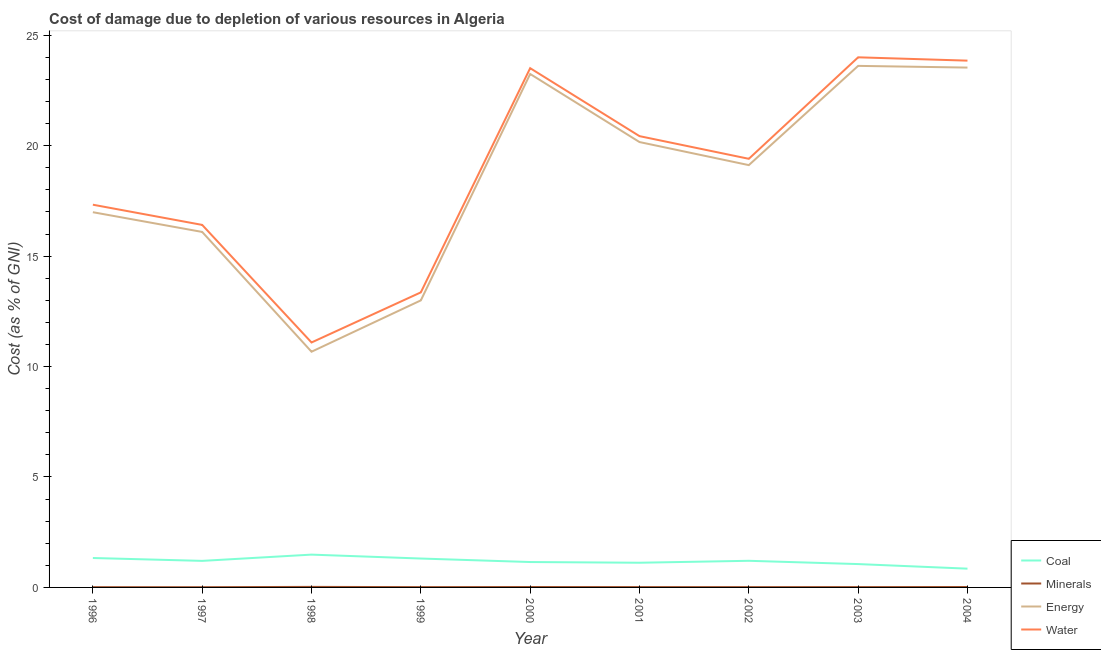How many different coloured lines are there?
Your answer should be compact. 4. What is the cost of damage due to depletion of coal in 2001?
Give a very brief answer. 1.12. Across all years, what is the maximum cost of damage due to depletion of water?
Offer a very short reply. 24. Across all years, what is the minimum cost of damage due to depletion of water?
Provide a short and direct response. 11.09. In which year was the cost of damage due to depletion of minerals maximum?
Give a very brief answer. 1998. In which year was the cost of damage due to depletion of minerals minimum?
Your answer should be compact. 1997. What is the total cost of damage due to depletion of energy in the graph?
Your response must be concise. 166.44. What is the difference between the cost of damage due to depletion of coal in 1997 and that in 1998?
Keep it short and to the point. -0.28. What is the difference between the cost of damage due to depletion of minerals in 2004 and the cost of damage due to depletion of energy in 1998?
Ensure brevity in your answer.  -10.65. What is the average cost of damage due to depletion of water per year?
Your answer should be compact. 18.82. In the year 2004, what is the difference between the cost of damage due to depletion of minerals and cost of damage due to depletion of water?
Offer a very short reply. -23.83. In how many years, is the cost of damage due to depletion of minerals greater than 16 %?
Offer a very short reply. 0. What is the ratio of the cost of damage due to depletion of energy in 1999 to that in 2004?
Give a very brief answer. 0.55. Is the cost of damage due to depletion of coal in 1998 less than that in 2000?
Your answer should be compact. No. What is the difference between the highest and the second highest cost of damage due to depletion of minerals?
Ensure brevity in your answer.  0.01. What is the difference between the highest and the lowest cost of damage due to depletion of coal?
Provide a short and direct response. 0.64. Is it the case that in every year, the sum of the cost of damage due to depletion of energy and cost of damage due to depletion of water is greater than the sum of cost of damage due to depletion of minerals and cost of damage due to depletion of coal?
Provide a short and direct response. Yes. Is the cost of damage due to depletion of coal strictly greater than the cost of damage due to depletion of minerals over the years?
Keep it short and to the point. Yes. Is the cost of damage due to depletion of coal strictly less than the cost of damage due to depletion of water over the years?
Give a very brief answer. Yes. How many lines are there?
Keep it short and to the point. 4. How many years are there in the graph?
Your response must be concise. 9. What is the difference between two consecutive major ticks on the Y-axis?
Provide a short and direct response. 5. Where does the legend appear in the graph?
Provide a succinct answer. Bottom right. What is the title of the graph?
Offer a very short reply. Cost of damage due to depletion of various resources in Algeria . Does "HFC gas" appear as one of the legend labels in the graph?
Offer a terse response. No. What is the label or title of the Y-axis?
Give a very brief answer. Cost (as % of GNI). What is the Cost (as % of GNI) of Coal in 1996?
Give a very brief answer. 1.33. What is the Cost (as % of GNI) of Minerals in 1996?
Offer a terse response. 0.01. What is the Cost (as % of GNI) of Energy in 1996?
Ensure brevity in your answer.  16.99. What is the Cost (as % of GNI) in Water in 1996?
Offer a terse response. 17.33. What is the Cost (as % of GNI) in Coal in 1997?
Your answer should be very brief. 1.2. What is the Cost (as % of GNI) in Minerals in 1997?
Offer a terse response. 0.01. What is the Cost (as % of GNI) of Energy in 1997?
Provide a short and direct response. 16.1. What is the Cost (as % of GNI) in Water in 1997?
Give a very brief answer. 16.41. What is the Cost (as % of GNI) of Coal in 1998?
Provide a short and direct response. 1.49. What is the Cost (as % of GNI) of Minerals in 1998?
Keep it short and to the point. 0.02. What is the Cost (as % of GNI) of Energy in 1998?
Offer a terse response. 10.67. What is the Cost (as % of GNI) in Water in 1998?
Give a very brief answer. 11.09. What is the Cost (as % of GNI) of Coal in 1999?
Keep it short and to the point. 1.31. What is the Cost (as % of GNI) of Minerals in 1999?
Your response must be concise. 0.01. What is the Cost (as % of GNI) of Energy in 1999?
Make the answer very short. 13. What is the Cost (as % of GNI) in Water in 1999?
Provide a short and direct response. 13.36. What is the Cost (as % of GNI) in Coal in 2000?
Provide a succinct answer. 1.15. What is the Cost (as % of GNI) in Minerals in 2000?
Offer a very short reply. 0.02. What is the Cost (as % of GNI) in Energy in 2000?
Provide a succinct answer. 23.25. What is the Cost (as % of GNI) in Water in 2000?
Your answer should be very brief. 23.51. What is the Cost (as % of GNI) in Coal in 2001?
Keep it short and to the point. 1.12. What is the Cost (as % of GNI) in Minerals in 2001?
Keep it short and to the point. 0.02. What is the Cost (as % of GNI) in Energy in 2001?
Offer a very short reply. 20.17. What is the Cost (as % of GNI) of Water in 2001?
Your answer should be very brief. 20.43. What is the Cost (as % of GNI) in Coal in 2002?
Offer a terse response. 1.21. What is the Cost (as % of GNI) of Minerals in 2002?
Give a very brief answer. 0.01. What is the Cost (as % of GNI) in Energy in 2002?
Make the answer very short. 19.12. What is the Cost (as % of GNI) in Water in 2002?
Your answer should be compact. 19.41. What is the Cost (as % of GNI) in Coal in 2003?
Your answer should be compact. 1.06. What is the Cost (as % of GNI) of Minerals in 2003?
Provide a short and direct response. 0.02. What is the Cost (as % of GNI) in Energy in 2003?
Give a very brief answer. 23.61. What is the Cost (as % of GNI) of Water in 2003?
Offer a terse response. 24. What is the Cost (as % of GNI) of Coal in 2004?
Your response must be concise. 0.85. What is the Cost (as % of GNI) of Minerals in 2004?
Offer a terse response. 0.02. What is the Cost (as % of GNI) of Energy in 2004?
Your response must be concise. 23.54. What is the Cost (as % of GNI) in Water in 2004?
Your answer should be very brief. 23.85. Across all years, what is the maximum Cost (as % of GNI) in Coal?
Your answer should be compact. 1.49. Across all years, what is the maximum Cost (as % of GNI) in Minerals?
Offer a terse response. 0.02. Across all years, what is the maximum Cost (as % of GNI) of Energy?
Keep it short and to the point. 23.61. Across all years, what is the maximum Cost (as % of GNI) of Water?
Make the answer very short. 24. Across all years, what is the minimum Cost (as % of GNI) in Coal?
Provide a short and direct response. 0.85. Across all years, what is the minimum Cost (as % of GNI) of Minerals?
Ensure brevity in your answer.  0.01. Across all years, what is the minimum Cost (as % of GNI) of Energy?
Your response must be concise. 10.67. Across all years, what is the minimum Cost (as % of GNI) in Water?
Your answer should be very brief. 11.09. What is the total Cost (as % of GNI) in Coal in the graph?
Your response must be concise. 10.71. What is the total Cost (as % of GNI) of Minerals in the graph?
Keep it short and to the point. 0.14. What is the total Cost (as % of GNI) of Energy in the graph?
Your response must be concise. 166.44. What is the total Cost (as % of GNI) of Water in the graph?
Keep it short and to the point. 169.4. What is the difference between the Cost (as % of GNI) of Coal in 1996 and that in 1997?
Make the answer very short. 0.13. What is the difference between the Cost (as % of GNI) of Minerals in 1996 and that in 1997?
Your answer should be compact. 0. What is the difference between the Cost (as % of GNI) in Energy in 1996 and that in 1997?
Provide a succinct answer. 0.89. What is the difference between the Cost (as % of GNI) of Water in 1996 and that in 1997?
Provide a short and direct response. 0.91. What is the difference between the Cost (as % of GNI) of Coal in 1996 and that in 1998?
Keep it short and to the point. -0.15. What is the difference between the Cost (as % of GNI) of Minerals in 1996 and that in 1998?
Offer a terse response. -0.01. What is the difference between the Cost (as % of GNI) of Energy in 1996 and that in 1998?
Ensure brevity in your answer.  6.32. What is the difference between the Cost (as % of GNI) in Water in 1996 and that in 1998?
Make the answer very short. 6.24. What is the difference between the Cost (as % of GNI) in Coal in 1996 and that in 1999?
Make the answer very short. 0.02. What is the difference between the Cost (as % of GNI) in Minerals in 1996 and that in 1999?
Offer a very short reply. -0. What is the difference between the Cost (as % of GNI) in Energy in 1996 and that in 1999?
Provide a succinct answer. 3.99. What is the difference between the Cost (as % of GNI) in Water in 1996 and that in 1999?
Your answer should be compact. 3.97. What is the difference between the Cost (as % of GNI) of Coal in 1996 and that in 2000?
Offer a very short reply. 0.18. What is the difference between the Cost (as % of GNI) of Minerals in 1996 and that in 2000?
Your response must be concise. -0.01. What is the difference between the Cost (as % of GNI) of Energy in 1996 and that in 2000?
Offer a terse response. -6.26. What is the difference between the Cost (as % of GNI) of Water in 1996 and that in 2000?
Offer a very short reply. -6.18. What is the difference between the Cost (as % of GNI) of Coal in 1996 and that in 2001?
Your answer should be very brief. 0.21. What is the difference between the Cost (as % of GNI) in Minerals in 1996 and that in 2001?
Provide a short and direct response. -0. What is the difference between the Cost (as % of GNI) of Energy in 1996 and that in 2001?
Your answer should be compact. -3.18. What is the difference between the Cost (as % of GNI) of Water in 1996 and that in 2001?
Ensure brevity in your answer.  -3.1. What is the difference between the Cost (as % of GNI) of Coal in 1996 and that in 2002?
Ensure brevity in your answer.  0.13. What is the difference between the Cost (as % of GNI) of Minerals in 1996 and that in 2002?
Make the answer very short. -0. What is the difference between the Cost (as % of GNI) of Energy in 1996 and that in 2002?
Keep it short and to the point. -2.13. What is the difference between the Cost (as % of GNI) of Water in 1996 and that in 2002?
Offer a very short reply. -2.08. What is the difference between the Cost (as % of GNI) in Coal in 1996 and that in 2003?
Make the answer very short. 0.28. What is the difference between the Cost (as % of GNI) in Minerals in 1996 and that in 2003?
Offer a very short reply. -0. What is the difference between the Cost (as % of GNI) in Energy in 1996 and that in 2003?
Your answer should be very brief. -6.63. What is the difference between the Cost (as % of GNI) in Water in 1996 and that in 2003?
Provide a short and direct response. -6.67. What is the difference between the Cost (as % of GNI) in Coal in 1996 and that in 2004?
Offer a very short reply. 0.48. What is the difference between the Cost (as % of GNI) in Minerals in 1996 and that in 2004?
Your answer should be very brief. -0.01. What is the difference between the Cost (as % of GNI) of Energy in 1996 and that in 2004?
Your answer should be very brief. -6.55. What is the difference between the Cost (as % of GNI) in Water in 1996 and that in 2004?
Offer a very short reply. -6.52. What is the difference between the Cost (as % of GNI) of Coal in 1997 and that in 1998?
Offer a terse response. -0.28. What is the difference between the Cost (as % of GNI) in Minerals in 1997 and that in 1998?
Make the answer very short. -0.01. What is the difference between the Cost (as % of GNI) in Energy in 1997 and that in 1998?
Your answer should be very brief. 5.42. What is the difference between the Cost (as % of GNI) in Water in 1997 and that in 1998?
Offer a terse response. 5.32. What is the difference between the Cost (as % of GNI) of Coal in 1997 and that in 1999?
Keep it short and to the point. -0.11. What is the difference between the Cost (as % of GNI) in Minerals in 1997 and that in 1999?
Offer a terse response. -0. What is the difference between the Cost (as % of GNI) of Energy in 1997 and that in 1999?
Keep it short and to the point. 3.1. What is the difference between the Cost (as % of GNI) of Water in 1997 and that in 1999?
Keep it short and to the point. 3.05. What is the difference between the Cost (as % of GNI) in Coal in 1997 and that in 2000?
Keep it short and to the point. 0.05. What is the difference between the Cost (as % of GNI) of Minerals in 1997 and that in 2000?
Provide a succinct answer. -0.01. What is the difference between the Cost (as % of GNI) of Energy in 1997 and that in 2000?
Provide a succinct answer. -7.15. What is the difference between the Cost (as % of GNI) of Water in 1997 and that in 2000?
Ensure brevity in your answer.  -7.1. What is the difference between the Cost (as % of GNI) of Coal in 1997 and that in 2001?
Your answer should be compact. 0.08. What is the difference between the Cost (as % of GNI) of Minerals in 1997 and that in 2001?
Keep it short and to the point. -0. What is the difference between the Cost (as % of GNI) in Energy in 1997 and that in 2001?
Your answer should be very brief. -4.07. What is the difference between the Cost (as % of GNI) in Water in 1997 and that in 2001?
Give a very brief answer. -4.02. What is the difference between the Cost (as % of GNI) of Coal in 1997 and that in 2002?
Your response must be concise. -0. What is the difference between the Cost (as % of GNI) in Minerals in 1997 and that in 2002?
Offer a very short reply. -0. What is the difference between the Cost (as % of GNI) of Energy in 1997 and that in 2002?
Provide a succinct answer. -3.03. What is the difference between the Cost (as % of GNI) in Water in 1997 and that in 2002?
Make the answer very short. -2.99. What is the difference between the Cost (as % of GNI) of Coal in 1997 and that in 2003?
Offer a terse response. 0.15. What is the difference between the Cost (as % of GNI) of Minerals in 1997 and that in 2003?
Your response must be concise. -0.01. What is the difference between the Cost (as % of GNI) of Energy in 1997 and that in 2003?
Offer a terse response. -7.52. What is the difference between the Cost (as % of GNI) in Water in 1997 and that in 2003?
Your answer should be very brief. -7.59. What is the difference between the Cost (as % of GNI) in Coal in 1997 and that in 2004?
Your answer should be very brief. 0.35. What is the difference between the Cost (as % of GNI) of Minerals in 1997 and that in 2004?
Offer a terse response. -0.01. What is the difference between the Cost (as % of GNI) of Energy in 1997 and that in 2004?
Provide a short and direct response. -7.44. What is the difference between the Cost (as % of GNI) of Water in 1997 and that in 2004?
Your answer should be very brief. -7.44. What is the difference between the Cost (as % of GNI) in Coal in 1998 and that in 1999?
Provide a short and direct response. 0.18. What is the difference between the Cost (as % of GNI) of Minerals in 1998 and that in 1999?
Your response must be concise. 0.01. What is the difference between the Cost (as % of GNI) in Energy in 1998 and that in 1999?
Keep it short and to the point. -2.32. What is the difference between the Cost (as % of GNI) of Water in 1998 and that in 1999?
Keep it short and to the point. -2.27. What is the difference between the Cost (as % of GNI) in Coal in 1998 and that in 2000?
Your response must be concise. 0.34. What is the difference between the Cost (as % of GNI) in Minerals in 1998 and that in 2000?
Ensure brevity in your answer.  0.01. What is the difference between the Cost (as % of GNI) in Energy in 1998 and that in 2000?
Provide a short and direct response. -12.58. What is the difference between the Cost (as % of GNI) of Water in 1998 and that in 2000?
Ensure brevity in your answer.  -12.42. What is the difference between the Cost (as % of GNI) of Coal in 1998 and that in 2001?
Give a very brief answer. 0.37. What is the difference between the Cost (as % of GNI) of Minerals in 1998 and that in 2001?
Offer a very short reply. 0.01. What is the difference between the Cost (as % of GNI) of Energy in 1998 and that in 2001?
Offer a very short reply. -9.49. What is the difference between the Cost (as % of GNI) of Water in 1998 and that in 2001?
Keep it short and to the point. -9.34. What is the difference between the Cost (as % of GNI) in Coal in 1998 and that in 2002?
Provide a succinct answer. 0.28. What is the difference between the Cost (as % of GNI) in Minerals in 1998 and that in 2002?
Offer a terse response. 0.01. What is the difference between the Cost (as % of GNI) in Energy in 1998 and that in 2002?
Provide a succinct answer. -8.45. What is the difference between the Cost (as % of GNI) of Water in 1998 and that in 2002?
Make the answer very short. -8.32. What is the difference between the Cost (as % of GNI) of Coal in 1998 and that in 2003?
Keep it short and to the point. 0.43. What is the difference between the Cost (as % of GNI) in Minerals in 1998 and that in 2003?
Offer a very short reply. 0.01. What is the difference between the Cost (as % of GNI) of Energy in 1998 and that in 2003?
Provide a short and direct response. -12.94. What is the difference between the Cost (as % of GNI) of Water in 1998 and that in 2003?
Make the answer very short. -12.91. What is the difference between the Cost (as % of GNI) of Coal in 1998 and that in 2004?
Ensure brevity in your answer.  0.64. What is the difference between the Cost (as % of GNI) in Minerals in 1998 and that in 2004?
Provide a succinct answer. 0.01. What is the difference between the Cost (as % of GNI) of Energy in 1998 and that in 2004?
Your answer should be very brief. -12.87. What is the difference between the Cost (as % of GNI) in Water in 1998 and that in 2004?
Offer a terse response. -12.76. What is the difference between the Cost (as % of GNI) of Coal in 1999 and that in 2000?
Offer a very short reply. 0.16. What is the difference between the Cost (as % of GNI) in Minerals in 1999 and that in 2000?
Offer a very short reply. -0. What is the difference between the Cost (as % of GNI) in Energy in 1999 and that in 2000?
Offer a terse response. -10.25. What is the difference between the Cost (as % of GNI) in Water in 1999 and that in 2000?
Keep it short and to the point. -10.15. What is the difference between the Cost (as % of GNI) in Coal in 1999 and that in 2001?
Offer a very short reply. 0.19. What is the difference between the Cost (as % of GNI) in Minerals in 1999 and that in 2001?
Make the answer very short. -0. What is the difference between the Cost (as % of GNI) of Energy in 1999 and that in 2001?
Offer a terse response. -7.17. What is the difference between the Cost (as % of GNI) in Water in 1999 and that in 2001?
Your answer should be compact. -7.07. What is the difference between the Cost (as % of GNI) in Coal in 1999 and that in 2002?
Offer a very short reply. 0.1. What is the difference between the Cost (as % of GNI) of Minerals in 1999 and that in 2002?
Your answer should be very brief. -0. What is the difference between the Cost (as % of GNI) in Energy in 1999 and that in 2002?
Offer a very short reply. -6.12. What is the difference between the Cost (as % of GNI) in Water in 1999 and that in 2002?
Make the answer very short. -6.05. What is the difference between the Cost (as % of GNI) of Coal in 1999 and that in 2003?
Provide a succinct answer. 0.25. What is the difference between the Cost (as % of GNI) in Minerals in 1999 and that in 2003?
Provide a short and direct response. -0. What is the difference between the Cost (as % of GNI) in Energy in 1999 and that in 2003?
Your answer should be very brief. -10.62. What is the difference between the Cost (as % of GNI) in Water in 1999 and that in 2003?
Provide a succinct answer. -10.64. What is the difference between the Cost (as % of GNI) in Coal in 1999 and that in 2004?
Your answer should be compact. 0.46. What is the difference between the Cost (as % of GNI) in Minerals in 1999 and that in 2004?
Give a very brief answer. -0. What is the difference between the Cost (as % of GNI) in Energy in 1999 and that in 2004?
Keep it short and to the point. -10.54. What is the difference between the Cost (as % of GNI) of Water in 1999 and that in 2004?
Offer a very short reply. -10.49. What is the difference between the Cost (as % of GNI) of Coal in 2000 and that in 2001?
Keep it short and to the point. 0.03. What is the difference between the Cost (as % of GNI) in Minerals in 2000 and that in 2001?
Ensure brevity in your answer.  0. What is the difference between the Cost (as % of GNI) of Energy in 2000 and that in 2001?
Your answer should be very brief. 3.08. What is the difference between the Cost (as % of GNI) of Water in 2000 and that in 2001?
Offer a very short reply. 3.08. What is the difference between the Cost (as % of GNI) of Coal in 2000 and that in 2002?
Ensure brevity in your answer.  -0.06. What is the difference between the Cost (as % of GNI) in Minerals in 2000 and that in 2002?
Your response must be concise. 0. What is the difference between the Cost (as % of GNI) of Energy in 2000 and that in 2002?
Your answer should be very brief. 4.13. What is the difference between the Cost (as % of GNI) in Water in 2000 and that in 2002?
Your answer should be compact. 4.1. What is the difference between the Cost (as % of GNI) of Coal in 2000 and that in 2003?
Your response must be concise. 0.09. What is the difference between the Cost (as % of GNI) of Minerals in 2000 and that in 2003?
Provide a succinct answer. 0. What is the difference between the Cost (as % of GNI) of Energy in 2000 and that in 2003?
Your response must be concise. -0.37. What is the difference between the Cost (as % of GNI) of Water in 2000 and that in 2003?
Offer a very short reply. -0.49. What is the difference between the Cost (as % of GNI) of Coal in 2000 and that in 2004?
Provide a succinct answer. 0.3. What is the difference between the Cost (as % of GNI) of Minerals in 2000 and that in 2004?
Make the answer very short. -0. What is the difference between the Cost (as % of GNI) of Energy in 2000 and that in 2004?
Give a very brief answer. -0.29. What is the difference between the Cost (as % of GNI) of Water in 2000 and that in 2004?
Offer a very short reply. -0.34. What is the difference between the Cost (as % of GNI) in Coal in 2001 and that in 2002?
Your answer should be very brief. -0.09. What is the difference between the Cost (as % of GNI) of Minerals in 2001 and that in 2002?
Your answer should be compact. 0. What is the difference between the Cost (as % of GNI) of Energy in 2001 and that in 2002?
Provide a succinct answer. 1.04. What is the difference between the Cost (as % of GNI) in Water in 2001 and that in 2002?
Ensure brevity in your answer.  1.03. What is the difference between the Cost (as % of GNI) in Coal in 2001 and that in 2003?
Your response must be concise. 0.06. What is the difference between the Cost (as % of GNI) of Minerals in 2001 and that in 2003?
Ensure brevity in your answer.  -0. What is the difference between the Cost (as % of GNI) of Energy in 2001 and that in 2003?
Offer a terse response. -3.45. What is the difference between the Cost (as % of GNI) of Water in 2001 and that in 2003?
Your answer should be compact. -3.57. What is the difference between the Cost (as % of GNI) of Coal in 2001 and that in 2004?
Your response must be concise. 0.27. What is the difference between the Cost (as % of GNI) of Minerals in 2001 and that in 2004?
Offer a very short reply. -0. What is the difference between the Cost (as % of GNI) of Energy in 2001 and that in 2004?
Your response must be concise. -3.37. What is the difference between the Cost (as % of GNI) of Water in 2001 and that in 2004?
Ensure brevity in your answer.  -3.42. What is the difference between the Cost (as % of GNI) in Coal in 2002 and that in 2003?
Your answer should be compact. 0.15. What is the difference between the Cost (as % of GNI) of Minerals in 2002 and that in 2003?
Provide a succinct answer. -0. What is the difference between the Cost (as % of GNI) in Energy in 2002 and that in 2003?
Keep it short and to the point. -4.49. What is the difference between the Cost (as % of GNI) of Water in 2002 and that in 2003?
Keep it short and to the point. -4.6. What is the difference between the Cost (as % of GNI) in Coal in 2002 and that in 2004?
Provide a short and direct response. 0.36. What is the difference between the Cost (as % of GNI) of Minerals in 2002 and that in 2004?
Ensure brevity in your answer.  -0. What is the difference between the Cost (as % of GNI) of Energy in 2002 and that in 2004?
Offer a very short reply. -4.42. What is the difference between the Cost (as % of GNI) of Water in 2002 and that in 2004?
Offer a very short reply. -4.44. What is the difference between the Cost (as % of GNI) of Coal in 2003 and that in 2004?
Your answer should be compact. 0.21. What is the difference between the Cost (as % of GNI) of Minerals in 2003 and that in 2004?
Give a very brief answer. -0. What is the difference between the Cost (as % of GNI) in Energy in 2003 and that in 2004?
Provide a short and direct response. 0.08. What is the difference between the Cost (as % of GNI) of Water in 2003 and that in 2004?
Make the answer very short. 0.15. What is the difference between the Cost (as % of GNI) in Coal in 1996 and the Cost (as % of GNI) in Minerals in 1997?
Make the answer very short. 1.32. What is the difference between the Cost (as % of GNI) of Coal in 1996 and the Cost (as % of GNI) of Energy in 1997?
Provide a succinct answer. -14.76. What is the difference between the Cost (as % of GNI) in Coal in 1996 and the Cost (as % of GNI) in Water in 1997?
Offer a terse response. -15.08. What is the difference between the Cost (as % of GNI) in Minerals in 1996 and the Cost (as % of GNI) in Energy in 1997?
Your answer should be very brief. -16.08. What is the difference between the Cost (as % of GNI) of Minerals in 1996 and the Cost (as % of GNI) of Water in 1997?
Offer a very short reply. -16.4. What is the difference between the Cost (as % of GNI) in Energy in 1996 and the Cost (as % of GNI) in Water in 1997?
Provide a short and direct response. 0.58. What is the difference between the Cost (as % of GNI) in Coal in 1996 and the Cost (as % of GNI) in Minerals in 1998?
Give a very brief answer. 1.31. What is the difference between the Cost (as % of GNI) in Coal in 1996 and the Cost (as % of GNI) in Energy in 1998?
Your answer should be compact. -9.34. What is the difference between the Cost (as % of GNI) in Coal in 1996 and the Cost (as % of GNI) in Water in 1998?
Offer a terse response. -9.76. What is the difference between the Cost (as % of GNI) of Minerals in 1996 and the Cost (as % of GNI) of Energy in 1998?
Keep it short and to the point. -10.66. What is the difference between the Cost (as % of GNI) in Minerals in 1996 and the Cost (as % of GNI) in Water in 1998?
Give a very brief answer. -11.08. What is the difference between the Cost (as % of GNI) in Energy in 1996 and the Cost (as % of GNI) in Water in 1998?
Your answer should be very brief. 5.9. What is the difference between the Cost (as % of GNI) in Coal in 1996 and the Cost (as % of GNI) in Minerals in 1999?
Offer a terse response. 1.32. What is the difference between the Cost (as % of GNI) in Coal in 1996 and the Cost (as % of GNI) in Energy in 1999?
Your answer should be compact. -11.66. What is the difference between the Cost (as % of GNI) of Coal in 1996 and the Cost (as % of GNI) of Water in 1999?
Offer a very short reply. -12.03. What is the difference between the Cost (as % of GNI) of Minerals in 1996 and the Cost (as % of GNI) of Energy in 1999?
Offer a terse response. -12.98. What is the difference between the Cost (as % of GNI) in Minerals in 1996 and the Cost (as % of GNI) in Water in 1999?
Offer a terse response. -13.35. What is the difference between the Cost (as % of GNI) of Energy in 1996 and the Cost (as % of GNI) of Water in 1999?
Make the answer very short. 3.63. What is the difference between the Cost (as % of GNI) of Coal in 1996 and the Cost (as % of GNI) of Minerals in 2000?
Make the answer very short. 1.31. What is the difference between the Cost (as % of GNI) of Coal in 1996 and the Cost (as % of GNI) of Energy in 2000?
Give a very brief answer. -21.91. What is the difference between the Cost (as % of GNI) of Coal in 1996 and the Cost (as % of GNI) of Water in 2000?
Offer a terse response. -22.18. What is the difference between the Cost (as % of GNI) in Minerals in 1996 and the Cost (as % of GNI) in Energy in 2000?
Your answer should be compact. -23.23. What is the difference between the Cost (as % of GNI) in Minerals in 1996 and the Cost (as % of GNI) in Water in 2000?
Ensure brevity in your answer.  -23.5. What is the difference between the Cost (as % of GNI) of Energy in 1996 and the Cost (as % of GNI) of Water in 2000?
Your answer should be very brief. -6.52. What is the difference between the Cost (as % of GNI) in Coal in 1996 and the Cost (as % of GNI) in Minerals in 2001?
Your answer should be very brief. 1.32. What is the difference between the Cost (as % of GNI) of Coal in 1996 and the Cost (as % of GNI) of Energy in 2001?
Your answer should be very brief. -18.83. What is the difference between the Cost (as % of GNI) of Coal in 1996 and the Cost (as % of GNI) of Water in 2001?
Your response must be concise. -19.1. What is the difference between the Cost (as % of GNI) of Minerals in 1996 and the Cost (as % of GNI) of Energy in 2001?
Your answer should be compact. -20.15. What is the difference between the Cost (as % of GNI) in Minerals in 1996 and the Cost (as % of GNI) in Water in 2001?
Your answer should be compact. -20.42. What is the difference between the Cost (as % of GNI) of Energy in 1996 and the Cost (as % of GNI) of Water in 2001?
Your answer should be compact. -3.44. What is the difference between the Cost (as % of GNI) of Coal in 1996 and the Cost (as % of GNI) of Minerals in 2002?
Your answer should be very brief. 1.32. What is the difference between the Cost (as % of GNI) in Coal in 1996 and the Cost (as % of GNI) in Energy in 2002?
Your answer should be very brief. -17.79. What is the difference between the Cost (as % of GNI) of Coal in 1996 and the Cost (as % of GNI) of Water in 2002?
Provide a succinct answer. -18.07. What is the difference between the Cost (as % of GNI) of Minerals in 1996 and the Cost (as % of GNI) of Energy in 2002?
Your answer should be very brief. -19.11. What is the difference between the Cost (as % of GNI) of Minerals in 1996 and the Cost (as % of GNI) of Water in 2002?
Your answer should be very brief. -19.39. What is the difference between the Cost (as % of GNI) of Energy in 1996 and the Cost (as % of GNI) of Water in 2002?
Offer a very short reply. -2.42. What is the difference between the Cost (as % of GNI) of Coal in 1996 and the Cost (as % of GNI) of Minerals in 2003?
Keep it short and to the point. 1.32. What is the difference between the Cost (as % of GNI) of Coal in 1996 and the Cost (as % of GNI) of Energy in 2003?
Your answer should be very brief. -22.28. What is the difference between the Cost (as % of GNI) in Coal in 1996 and the Cost (as % of GNI) in Water in 2003?
Your answer should be very brief. -22.67. What is the difference between the Cost (as % of GNI) of Minerals in 1996 and the Cost (as % of GNI) of Energy in 2003?
Your answer should be compact. -23.6. What is the difference between the Cost (as % of GNI) in Minerals in 1996 and the Cost (as % of GNI) in Water in 2003?
Give a very brief answer. -23.99. What is the difference between the Cost (as % of GNI) of Energy in 1996 and the Cost (as % of GNI) of Water in 2003?
Offer a terse response. -7.01. What is the difference between the Cost (as % of GNI) in Coal in 1996 and the Cost (as % of GNI) in Minerals in 2004?
Provide a succinct answer. 1.31. What is the difference between the Cost (as % of GNI) in Coal in 1996 and the Cost (as % of GNI) in Energy in 2004?
Make the answer very short. -22.21. What is the difference between the Cost (as % of GNI) of Coal in 1996 and the Cost (as % of GNI) of Water in 2004?
Your answer should be very brief. -22.52. What is the difference between the Cost (as % of GNI) in Minerals in 1996 and the Cost (as % of GNI) in Energy in 2004?
Provide a succinct answer. -23.52. What is the difference between the Cost (as % of GNI) of Minerals in 1996 and the Cost (as % of GNI) of Water in 2004?
Provide a succinct answer. -23.84. What is the difference between the Cost (as % of GNI) in Energy in 1996 and the Cost (as % of GNI) in Water in 2004?
Make the answer very short. -6.86. What is the difference between the Cost (as % of GNI) of Coal in 1997 and the Cost (as % of GNI) of Minerals in 1998?
Provide a succinct answer. 1.18. What is the difference between the Cost (as % of GNI) in Coal in 1997 and the Cost (as % of GNI) in Energy in 1998?
Ensure brevity in your answer.  -9.47. What is the difference between the Cost (as % of GNI) of Coal in 1997 and the Cost (as % of GNI) of Water in 1998?
Your response must be concise. -9.89. What is the difference between the Cost (as % of GNI) in Minerals in 1997 and the Cost (as % of GNI) in Energy in 1998?
Your answer should be compact. -10.66. What is the difference between the Cost (as % of GNI) of Minerals in 1997 and the Cost (as % of GNI) of Water in 1998?
Your answer should be compact. -11.08. What is the difference between the Cost (as % of GNI) of Energy in 1997 and the Cost (as % of GNI) of Water in 1998?
Your answer should be compact. 5.01. What is the difference between the Cost (as % of GNI) in Coal in 1997 and the Cost (as % of GNI) in Minerals in 1999?
Provide a succinct answer. 1.19. What is the difference between the Cost (as % of GNI) of Coal in 1997 and the Cost (as % of GNI) of Energy in 1999?
Keep it short and to the point. -11.79. What is the difference between the Cost (as % of GNI) of Coal in 1997 and the Cost (as % of GNI) of Water in 1999?
Provide a short and direct response. -12.16. What is the difference between the Cost (as % of GNI) of Minerals in 1997 and the Cost (as % of GNI) of Energy in 1999?
Offer a very short reply. -12.99. What is the difference between the Cost (as % of GNI) in Minerals in 1997 and the Cost (as % of GNI) in Water in 1999?
Give a very brief answer. -13.35. What is the difference between the Cost (as % of GNI) of Energy in 1997 and the Cost (as % of GNI) of Water in 1999?
Make the answer very short. 2.74. What is the difference between the Cost (as % of GNI) in Coal in 1997 and the Cost (as % of GNI) in Minerals in 2000?
Keep it short and to the point. 1.18. What is the difference between the Cost (as % of GNI) in Coal in 1997 and the Cost (as % of GNI) in Energy in 2000?
Make the answer very short. -22.05. What is the difference between the Cost (as % of GNI) of Coal in 1997 and the Cost (as % of GNI) of Water in 2000?
Your answer should be compact. -22.31. What is the difference between the Cost (as % of GNI) of Minerals in 1997 and the Cost (as % of GNI) of Energy in 2000?
Keep it short and to the point. -23.24. What is the difference between the Cost (as % of GNI) of Minerals in 1997 and the Cost (as % of GNI) of Water in 2000?
Make the answer very short. -23.5. What is the difference between the Cost (as % of GNI) of Energy in 1997 and the Cost (as % of GNI) of Water in 2000?
Ensure brevity in your answer.  -7.41. What is the difference between the Cost (as % of GNI) in Coal in 1997 and the Cost (as % of GNI) in Minerals in 2001?
Offer a terse response. 1.19. What is the difference between the Cost (as % of GNI) in Coal in 1997 and the Cost (as % of GNI) in Energy in 2001?
Give a very brief answer. -18.96. What is the difference between the Cost (as % of GNI) in Coal in 1997 and the Cost (as % of GNI) in Water in 2001?
Your response must be concise. -19.23. What is the difference between the Cost (as % of GNI) in Minerals in 1997 and the Cost (as % of GNI) in Energy in 2001?
Your answer should be compact. -20.15. What is the difference between the Cost (as % of GNI) of Minerals in 1997 and the Cost (as % of GNI) of Water in 2001?
Ensure brevity in your answer.  -20.42. What is the difference between the Cost (as % of GNI) in Energy in 1997 and the Cost (as % of GNI) in Water in 2001?
Make the answer very short. -4.34. What is the difference between the Cost (as % of GNI) in Coal in 1997 and the Cost (as % of GNI) in Minerals in 2002?
Ensure brevity in your answer.  1.19. What is the difference between the Cost (as % of GNI) in Coal in 1997 and the Cost (as % of GNI) in Energy in 2002?
Your response must be concise. -17.92. What is the difference between the Cost (as % of GNI) of Coal in 1997 and the Cost (as % of GNI) of Water in 2002?
Offer a terse response. -18.2. What is the difference between the Cost (as % of GNI) in Minerals in 1997 and the Cost (as % of GNI) in Energy in 2002?
Ensure brevity in your answer.  -19.11. What is the difference between the Cost (as % of GNI) in Minerals in 1997 and the Cost (as % of GNI) in Water in 2002?
Keep it short and to the point. -19.4. What is the difference between the Cost (as % of GNI) of Energy in 1997 and the Cost (as % of GNI) of Water in 2002?
Offer a very short reply. -3.31. What is the difference between the Cost (as % of GNI) of Coal in 1997 and the Cost (as % of GNI) of Minerals in 2003?
Keep it short and to the point. 1.19. What is the difference between the Cost (as % of GNI) of Coal in 1997 and the Cost (as % of GNI) of Energy in 2003?
Your response must be concise. -22.41. What is the difference between the Cost (as % of GNI) in Coal in 1997 and the Cost (as % of GNI) in Water in 2003?
Make the answer very short. -22.8. What is the difference between the Cost (as % of GNI) of Minerals in 1997 and the Cost (as % of GNI) of Energy in 2003?
Your response must be concise. -23.6. What is the difference between the Cost (as % of GNI) of Minerals in 1997 and the Cost (as % of GNI) of Water in 2003?
Offer a very short reply. -23.99. What is the difference between the Cost (as % of GNI) of Energy in 1997 and the Cost (as % of GNI) of Water in 2003?
Make the answer very short. -7.91. What is the difference between the Cost (as % of GNI) of Coal in 1997 and the Cost (as % of GNI) of Minerals in 2004?
Your answer should be compact. 1.18. What is the difference between the Cost (as % of GNI) in Coal in 1997 and the Cost (as % of GNI) in Energy in 2004?
Your answer should be very brief. -22.34. What is the difference between the Cost (as % of GNI) in Coal in 1997 and the Cost (as % of GNI) in Water in 2004?
Offer a very short reply. -22.65. What is the difference between the Cost (as % of GNI) of Minerals in 1997 and the Cost (as % of GNI) of Energy in 2004?
Provide a succinct answer. -23.53. What is the difference between the Cost (as % of GNI) in Minerals in 1997 and the Cost (as % of GNI) in Water in 2004?
Keep it short and to the point. -23.84. What is the difference between the Cost (as % of GNI) of Energy in 1997 and the Cost (as % of GNI) of Water in 2004?
Ensure brevity in your answer.  -7.76. What is the difference between the Cost (as % of GNI) in Coal in 1998 and the Cost (as % of GNI) in Minerals in 1999?
Ensure brevity in your answer.  1.47. What is the difference between the Cost (as % of GNI) of Coal in 1998 and the Cost (as % of GNI) of Energy in 1999?
Provide a short and direct response. -11.51. What is the difference between the Cost (as % of GNI) in Coal in 1998 and the Cost (as % of GNI) in Water in 1999?
Provide a short and direct response. -11.87. What is the difference between the Cost (as % of GNI) of Minerals in 1998 and the Cost (as % of GNI) of Energy in 1999?
Your answer should be compact. -12.97. What is the difference between the Cost (as % of GNI) in Minerals in 1998 and the Cost (as % of GNI) in Water in 1999?
Your response must be concise. -13.34. What is the difference between the Cost (as % of GNI) of Energy in 1998 and the Cost (as % of GNI) of Water in 1999?
Your response must be concise. -2.69. What is the difference between the Cost (as % of GNI) in Coal in 1998 and the Cost (as % of GNI) in Minerals in 2000?
Make the answer very short. 1.47. What is the difference between the Cost (as % of GNI) in Coal in 1998 and the Cost (as % of GNI) in Energy in 2000?
Offer a very short reply. -21.76. What is the difference between the Cost (as % of GNI) in Coal in 1998 and the Cost (as % of GNI) in Water in 2000?
Ensure brevity in your answer.  -22.02. What is the difference between the Cost (as % of GNI) in Minerals in 1998 and the Cost (as % of GNI) in Energy in 2000?
Offer a very short reply. -23.22. What is the difference between the Cost (as % of GNI) of Minerals in 1998 and the Cost (as % of GNI) of Water in 2000?
Offer a terse response. -23.49. What is the difference between the Cost (as % of GNI) of Energy in 1998 and the Cost (as % of GNI) of Water in 2000?
Provide a short and direct response. -12.84. What is the difference between the Cost (as % of GNI) in Coal in 1998 and the Cost (as % of GNI) in Minerals in 2001?
Your answer should be very brief. 1.47. What is the difference between the Cost (as % of GNI) of Coal in 1998 and the Cost (as % of GNI) of Energy in 2001?
Ensure brevity in your answer.  -18.68. What is the difference between the Cost (as % of GNI) of Coal in 1998 and the Cost (as % of GNI) of Water in 2001?
Provide a short and direct response. -18.95. What is the difference between the Cost (as % of GNI) in Minerals in 1998 and the Cost (as % of GNI) in Energy in 2001?
Give a very brief answer. -20.14. What is the difference between the Cost (as % of GNI) of Minerals in 1998 and the Cost (as % of GNI) of Water in 2001?
Offer a terse response. -20.41. What is the difference between the Cost (as % of GNI) in Energy in 1998 and the Cost (as % of GNI) in Water in 2001?
Your answer should be compact. -9.76. What is the difference between the Cost (as % of GNI) of Coal in 1998 and the Cost (as % of GNI) of Minerals in 2002?
Offer a very short reply. 1.47. What is the difference between the Cost (as % of GNI) in Coal in 1998 and the Cost (as % of GNI) in Energy in 2002?
Provide a succinct answer. -17.64. What is the difference between the Cost (as % of GNI) in Coal in 1998 and the Cost (as % of GNI) in Water in 2002?
Offer a terse response. -17.92. What is the difference between the Cost (as % of GNI) in Minerals in 1998 and the Cost (as % of GNI) in Energy in 2002?
Your answer should be very brief. -19.1. What is the difference between the Cost (as % of GNI) in Minerals in 1998 and the Cost (as % of GNI) in Water in 2002?
Your answer should be very brief. -19.38. What is the difference between the Cost (as % of GNI) in Energy in 1998 and the Cost (as % of GNI) in Water in 2002?
Your response must be concise. -8.73. What is the difference between the Cost (as % of GNI) of Coal in 1998 and the Cost (as % of GNI) of Minerals in 2003?
Ensure brevity in your answer.  1.47. What is the difference between the Cost (as % of GNI) of Coal in 1998 and the Cost (as % of GNI) of Energy in 2003?
Ensure brevity in your answer.  -22.13. What is the difference between the Cost (as % of GNI) of Coal in 1998 and the Cost (as % of GNI) of Water in 2003?
Provide a short and direct response. -22.52. What is the difference between the Cost (as % of GNI) in Minerals in 1998 and the Cost (as % of GNI) in Energy in 2003?
Offer a very short reply. -23.59. What is the difference between the Cost (as % of GNI) of Minerals in 1998 and the Cost (as % of GNI) of Water in 2003?
Your answer should be very brief. -23.98. What is the difference between the Cost (as % of GNI) in Energy in 1998 and the Cost (as % of GNI) in Water in 2003?
Provide a succinct answer. -13.33. What is the difference between the Cost (as % of GNI) in Coal in 1998 and the Cost (as % of GNI) in Minerals in 2004?
Offer a terse response. 1.47. What is the difference between the Cost (as % of GNI) in Coal in 1998 and the Cost (as % of GNI) in Energy in 2004?
Give a very brief answer. -22.05. What is the difference between the Cost (as % of GNI) of Coal in 1998 and the Cost (as % of GNI) of Water in 2004?
Offer a terse response. -22.37. What is the difference between the Cost (as % of GNI) of Minerals in 1998 and the Cost (as % of GNI) of Energy in 2004?
Your answer should be very brief. -23.51. What is the difference between the Cost (as % of GNI) in Minerals in 1998 and the Cost (as % of GNI) in Water in 2004?
Offer a terse response. -23.83. What is the difference between the Cost (as % of GNI) of Energy in 1998 and the Cost (as % of GNI) of Water in 2004?
Offer a terse response. -13.18. What is the difference between the Cost (as % of GNI) in Coal in 1999 and the Cost (as % of GNI) in Minerals in 2000?
Your response must be concise. 1.29. What is the difference between the Cost (as % of GNI) in Coal in 1999 and the Cost (as % of GNI) in Energy in 2000?
Provide a succinct answer. -21.94. What is the difference between the Cost (as % of GNI) in Coal in 1999 and the Cost (as % of GNI) in Water in 2000?
Give a very brief answer. -22.2. What is the difference between the Cost (as % of GNI) in Minerals in 1999 and the Cost (as % of GNI) in Energy in 2000?
Ensure brevity in your answer.  -23.23. What is the difference between the Cost (as % of GNI) of Minerals in 1999 and the Cost (as % of GNI) of Water in 2000?
Your answer should be compact. -23.5. What is the difference between the Cost (as % of GNI) in Energy in 1999 and the Cost (as % of GNI) in Water in 2000?
Your answer should be very brief. -10.51. What is the difference between the Cost (as % of GNI) of Coal in 1999 and the Cost (as % of GNI) of Minerals in 2001?
Offer a terse response. 1.29. What is the difference between the Cost (as % of GNI) in Coal in 1999 and the Cost (as % of GNI) in Energy in 2001?
Make the answer very short. -18.86. What is the difference between the Cost (as % of GNI) of Coal in 1999 and the Cost (as % of GNI) of Water in 2001?
Your answer should be compact. -19.13. What is the difference between the Cost (as % of GNI) of Minerals in 1999 and the Cost (as % of GNI) of Energy in 2001?
Make the answer very short. -20.15. What is the difference between the Cost (as % of GNI) in Minerals in 1999 and the Cost (as % of GNI) in Water in 2001?
Your answer should be very brief. -20.42. What is the difference between the Cost (as % of GNI) in Energy in 1999 and the Cost (as % of GNI) in Water in 2001?
Your answer should be compact. -7.44. What is the difference between the Cost (as % of GNI) in Coal in 1999 and the Cost (as % of GNI) in Minerals in 2002?
Your answer should be very brief. 1.29. What is the difference between the Cost (as % of GNI) in Coal in 1999 and the Cost (as % of GNI) in Energy in 2002?
Make the answer very short. -17.81. What is the difference between the Cost (as % of GNI) of Coal in 1999 and the Cost (as % of GNI) of Water in 2002?
Ensure brevity in your answer.  -18.1. What is the difference between the Cost (as % of GNI) of Minerals in 1999 and the Cost (as % of GNI) of Energy in 2002?
Offer a very short reply. -19.11. What is the difference between the Cost (as % of GNI) in Minerals in 1999 and the Cost (as % of GNI) in Water in 2002?
Your answer should be compact. -19.39. What is the difference between the Cost (as % of GNI) in Energy in 1999 and the Cost (as % of GNI) in Water in 2002?
Offer a terse response. -6.41. What is the difference between the Cost (as % of GNI) of Coal in 1999 and the Cost (as % of GNI) of Minerals in 2003?
Keep it short and to the point. 1.29. What is the difference between the Cost (as % of GNI) in Coal in 1999 and the Cost (as % of GNI) in Energy in 2003?
Your response must be concise. -22.31. What is the difference between the Cost (as % of GNI) in Coal in 1999 and the Cost (as % of GNI) in Water in 2003?
Offer a terse response. -22.69. What is the difference between the Cost (as % of GNI) of Minerals in 1999 and the Cost (as % of GNI) of Energy in 2003?
Ensure brevity in your answer.  -23.6. What is the difference between the Cost (as % of GNI) in Minerals in 1999 and the Cost (as % of GNI) in Water in 2003?
Ensure brevity in your answer.  -23.99. What is the difference between the Cost (as % of GNI) of Energy in 1999 and the Cost (as % of GNI) of Water in 2003?
Ensure brevity in your answer.  -11. What is the difference between the Cost (as % of GNI) in Coal in 1999 and the Cost (as % of GNI) in Minerals in 2004?
Offer a terse response. 1.29. What is the difference between the Cost (as % of GNI) of Coal in 1999 and the Cost (as % of GNI) of Energy in 2004?
Provide a succinct answer. -22.23. What is the difference between the Cost (as % of GNI) of Coal in 1999 and the Cost (as % of GNI) of Water in 2004?
Provide a succinct answer. -22.54. What is the difference between the Cost (as % of GNI) in Minerals in 1999 and the Cost (as % of GNI) in Energy in 2004?
Give a very brief answer. -23.52. What is the difference between the Cost (as % of GNI) of Minerals in 1999 and the Cost (as % of GNI) of Water in 2004?
Provide a short and direct response. -23.84. What is the difference between the Cost (as % of GNI) in Energy in 1999 and the Cost (as % of GNI) in Water in 2004?
Offer a terse response. -10.85. What is the difference between the Cost (as % of GNI) of Coal in 2000 and the Cost (as % of GNI) of Minerals in 2001?
Make the answer very short. 1.13. What is the difference between the Cost (as % of GNI) of Coal in 2000 and the Cost (as % of GNI) of Energy in 2001?
Your response must be concise. -19.02. What is the difference between the Cost (as % of GNI) of Coal in 2000 and the Cost (as % of GNI) of Water in 2001?
Keep it short and to the point. -19.28. What is the difference between the Cost (as % of GNI) in Minerals in 2000 and the Cost (as % of GNI) in Energy in 2001?
Provide a succinct answer. -20.15. What is the difference between the Cost (as % of GNI) of Minerals in 2000 and the Cost (as % of GNI) of Water in 2001?
Offer a very short reply. -20.41. What is the difference between the Cost (as % of GNI) of Energy in 2000 and the Cost (as % of GNI) of Water in 2001?
Provide a succinct answer. 2.81. What is the difference between the Cost (as % of GNI) in Coal in 2000 and the Cost (as % of GNI) in Minerals in 2002?
Keep it short and to the point. 1.14. What is the difference between the Cost (as % of GNI) in Coal in 2000 and the Cost (as % of GNI) in Energy in 2002?
Ensure brevity in your answer.  -17.97. What is the difference between the Cost (as % of GNI) in Coal in 2000 and the Cost (as % of GNI) in Water in 2002?
Offer a very short reply. -18.26. What is the difference between the Cost (as % of GNI) in Minerals in 2000 and the Cost (as % of GNI) in Energy in 2002?
Give a very brief answer. -19.1. What is the difference between the Cost (as % of GNI) in Minerals in 2000 and the Cost (as % of GNI) in Water in 2002?
Make the answer very short. -19.39. What is the difference between the Cost (as % of GNI) in Energy in 2000 and the Cost (as % of GNI) in Water in 2002?
Provide a succinct answer. 3.84. What is the difference between the Cost (as % of GNI) of Coal in 2000 and the Cost (as % of GNI) of Minerals in 2003?
Your answer should be compact. 1.13. What is the difference between the Cost (as % of GNI) of Coal in 2000 and the Cost (as % of GNI) of Energy in 2003?
Ensure brevity in your answer.  -22.46. What is the difference between the Cost (as % of GNI) of Coal in 2000 and the Cost (as % of GNI) of Water in 2003?
Your answer should be compact. -22.85. What is the difference between the Cost (as % of GNI) in Minerals in 2000 and the Cost (as % of GNI) in Energy in 2003?
Give a very brief answer. -23.6. What is the difference between the Cost (as % of GNI) in Minerals in 2000 and the Cost (as % of GNI) in Water in 2003?
Make the answer very short. -23.98. What is the difference between the Cost (as % of GNI) of Energy in 2000 and the Cost (as % of GNI) of Water in 2003?
Provide a short and direct response. -0.75. What is the difference between the Cost (as % of GNI) of Coal in 2000 and the Cost (as % of GNI) of Minerals in 2004?
Ensure brevity in your answer.  1.13. What is the difference between the Cost (as % of GNI) of Coal in 2000 and the Cost (as % of GNI) of Energy in 2004?
Your answer should be very brief. -22.39. What is the difference between the Cost (as % of GNI) in Coal in 2000 and the Cost (as % of GNI) in Water in 2004?
Offer a terse response. -22.7. What is the difference between the Cost (as % of GNI) in Minerals in 2000 and the Cost (as % of GNI) in Energy in 2004?
Offer a very short reply. -23.52. What is the difference between the Cost (as % of GNI) of Minerals in 2000 and the Cost (as % of GNI) of Water in 2004?
Offer a terse response. -23.83. What is the difference between the Cost (as % of GNI) of Energy in 2000 and the Cost (as % of GNI) of Water in 2004?
Your answer should be very brief. -0.6. What is the difference between the Cost (as % of GNI) in Coal in 2001 and the Cost (as % of GNI) in Minerals in 2002?
Provide a succinct answer. 1.1. What is the difference between the Cost (as % of GNI) in Coal in 2001 and the Cost (as % of GNI) in Energy in 2002?
Give a very brief answer. -18. What is the difference between the Cost (as % of GNI) of Coal in 2001 and the Cost (as % of GNI) of Water in 2002?
Your answer should be very brief. -18.29. What is the difference between the Cost (as % of GNI) in Minerals in 2001 and the Cost (as % of GNI) in Energy in 2002?
Your answer should be very brief. -19.11. What is the difference between the Cost (as % of GNI) of Minerals in 2001 and the Cost (as % of GNI) of Water in 2002?
Your answer should be very brief. -19.39. What is the difference between the Cost (as % of GNI) in Energy in 2001 and the Cost (as % of GNI) in Water in 2002?
Offer a terse response. 0.76. What is the difference between the Cost (as % of GNI) of Coal in 2001 and the Cost (as % of GNI) of Minerals in 2003?
Your answer should be very brief. 1.1. What is the difference between the Cost (as % of GNI) in Coal in 2001 and the Cost (as % of GNI) in Energy in 2003?
Your answer should be very brief. -22.5. What is the difference between the Cost (as % of GNI) of Coal in 2001 and the Cost (as % of GNI) of Water in 2003?
Provide a succinct answer. -22.88. What is the difference between the Cost (as % of GNI) in Minerals in 2001 and the Cost (as % of GNI) in Energy in 2003?
Ensure brevity in your answer.  -23.6. What is the difference between the Cost (as % of GNI) in Minerals in 2001 and the Cost (as % of GNI) in Water in 2003?
Provide a short and direct response. -23.99. What is the difference between the Cost (as % of GNI) in Energy in 2001 and the Cost (as % of GNI) in Water in 2003?
Ensure brevity in your answer.  -3.84. What is the difference between the Cost (as % of GNI) in Coal in 2001 and the Cost (as % of GNI) in Minerals in 2004?
Your response must be concise. 1.1. What is the difference between the Cost (as % of GNI) of Coal in 2001 and the Cost (as % of GNI) of Energy in 2004?
Your response must be concise. -22.42. What is the difference between the Cost (as % of GNI) of Coal in 2001 and the Cost (as % of GNI) of Water in 2004?
Keep it short and to the point. -22.73. What is the difference between the Cost (as % of GNI) of Minerals in 2001 and the Cost (as % of GNI) of Energy in 2004?
Offer a very short reply. -23.52. What is the difference between the Cost (as % of GNI) in Minerals in 2001 and the Cost (as % of GNI) in Water in 2004?
Your answer should be compact. -23.84. What is the difference between the Cost (as % of GNI) in Energy in 2001 and the Cost (as % of GNI) in Water in 2004?
Offer a terse response. -3.69. What is the difference between the Cost (as % of GNI) in Coal in 2002 and the Cost (as % of GNI) in Minerals in 2003?
Ensure brevity in your answer.  1.19. What is the difference between the Cost (as % of GNI) of Coal in 2002 and the Cost (as % of GNI) of Energy in 2003?
Keep it short and to the point. -22.41. What is the difference between the Cost (as % of GNI) in Coal in 2002 and the Cost (as % of GNI) in Water in 2003?
Offer a very short reply. -22.8. What is the difference between the Cost (as % of GNI) in Minerals in 2002 and the Cost (as % of GNI) in Energy in 2003?
Offer a very short reply. -23.6. What is the difference between the Cost (as % of GNI) of Minerals in 2002 and the Cost (as % of GNI) of Water in 2003?
Provide a short and direct response. -23.99. What is the difference between the Cost (as % of GNI) in Energy in 2002 and the Cost (as % of GNI) in Water in 2003?
Make the answer very short. -4.88. What is the difference between the Cost (as % of GNI) in Coal in 2002 and the Cost (as % of GNI) in Minerals in 2004?
Offer a very short reply. 1.19. What is the difference between the Cost (as % of GNI) of Coal in 2002 and the Cost (as % of GNI) of Energy in 2004?
Offer a terse response. -22.33. What is the difference between the Cost (as % of GNI) in Coal in 2002 and the Cost (as % of GNI) in Water in 2004?
Give a very brief answer. -22.65. What is the difference between the Cost (as % of GNI) in Minerals in 2002 and the Cost (as % of GNI) in Energy in 2004?
Provide a succinct answer. -23.52. What is the difference between the Cost (as % of GNI) of Minerals in 2002 and the Cost (as % of GNI) of Water in 2004?
Your answer should be compact. -23.84. What is the difference between the Cost (as % of GNI) in Energy in 2002 and the Cost (as % of GNI) in Water in 2004?
Keep it short and to the point. -4.73. What is the difference between the Cost (as % of GNI) in Coal in 2003 and the Cost (as % of GNI) in Minerals in 2004?
Ensure brevity in your answer.  1.04. What is the difference between the Cost (as % of GNI) of Coal in 2003 and the Cost (as % of GNI) of Energy in 2004?
Your response must be concise. -22.48. What is the difference between the Cost (as % of GNI) of Coal in 2003 and the Cost (as % of GNI) of Water in 2004?
Give a very brief answer. -22.79. What is the difference between the Cost (as % of GNI) of Minerals in 2003 and the Cost (as % of GNI) of Energy in 2004?
Offer a very short reply. -23.52. What is the difference between the Cost (as % of GNI) in Minerals in 2003 and the Cost (as % of GNI) in Water in 2004?
Your answer should be compact. -23.84. What is the difference between the Cost (as % of GNI) of Energy in 2003 and the Cost (as % of GNI) of Water in 2004?
Ensure brevity in your answer.  -0.24. What is the average Cost (as % of GNI) of Coal per year?
Provide a short and direct response. 1.19. What is the average Cost (as % of GNI) in Minerals per year?
Offer a very short reply. 0.02. What is the average Cost (as % of GNI) of Energy per year?
Your answer should be very brief. 18.49. What is the average Cost (as % of GNI) in Water per year?
Ensure brevity in your answer.  18.82. In the year 1996, what is the difference between the Cost (as % of GNI) of Coal and Cost (as % of GNI) of Minerals?
Keep it short and to the point. 1.32. In the year 1996, what is the difference between the Cost (as % of GNI) of Coal and Cost (as % of GNI) of Energy?
Provide a succinct answer. -15.66. In the year 1996, what is the difference between the Cost (as % of GNI) of Coal and Cost (as % of GNI) of Water?
Make the answer very short. -16. In the year 1996, what is the difference between the Cost (as % of GNI) in Minerals and Cost (as % of GNI) in Energy?
Your answer should be compact. -16.98. In the year 1996, what is the difference between the Cost (as % of GNI) in Minerals and Cost (as % of GNI) in Water?
Give a very brief answer. -17.32. In the year 1996, what is the difference between the Cost (as % of GNI) in Energy and Cost (as % of GNI) in Water?
Keep it short and to the point. -0.34. In the year 1997, what is the difference between the Cost (as % of GNI) of Coal and Cost (as % of GNI) of Minerals?
Provide a short and direct response. 1.19. In the year 1997, what is the difference between the Cost (as % of GNI) of Coal and Cost (as % of GNI) of Energy?
Keep it short and to the point. -14.89. In the year 1997, what is the difference between the Cost (as % of GNI) of Coal and Cost (as % of GNI) of Water?
Your response must be concise. -15.21. In the year 1997, what is the difference between the Cost (as % of GNI) in Minerals and Cost (as % of GNI) in Energy?
Ensure brevity in your answer.  -16.09. In the year 1997, what is the difference between the Cost (as % of GNI) in Minerals and Cost (as % of GNI) in Water?
Keep it short and to the point. -16.4. In the year 1997, what is the difference between the Cost (as % of GNI) of Energy and Cost (as % of GNI) of Water?
Provide a succinct answer. -0.32. In the year 1998, what is the difference between the Cost (as % of GNI) in Coal and Cost (as % of GNI) in Minerals?
Keep it short and to the point. 1.46. In the year 1998, what is the difference between the Cost (as % of GNI) of Coal and Cost (as % of GNI) of Energy?
Your answer should be compact. -9.19. In the year 1998, what is the difference between the Cost (as % of GNI) in Coal and Cost (as % of GNI) in Water?
Ensure brevity in your answer.  -9.61. In the year 1998, what is the difference between the Cost (as % of GNI) of Minerals and Cost (as % of GNI) of Energy?
Your answer should be compact. -10.65. In the year 1998, what is the difference between the Cost (as % of GNI) of Minerals and Cost (as % of GNI) of Water?
Your response must be concise. -11.07. In the year 1998, what is the difference between the Cost (as % of GNI) in Energy and Cost (as % of GNI) in Water?
Offer a very short reply. -0.42. In the year 1999, what is the difference between the Cost (as % of GNI) of Coal and Cost (as % of GNI) of Minerals?
Offer a terse response. 1.29. In the year 1999, what is the difference between the Cost (as % of GNI) in Coal and Cost (as % of GNI) in Energy?
Your response must be concise. -11.69. In the year 1999, what is the difference between the Cost (as % of GNI) in Coal and Cost (as % of GNI) in Water?
Ensure brevity in your answer.  -12.05. In the year 1999, what is the difference between the Cost (as % of GNI) in Minerals and Cost (as % of GNI) in Energy?
Ensure brevity in your answer.  -12.98. In the year 1999, what is the difference between the Cost (as % of GNI) of Minerals and Cost (as % of GNI) of Water?
Your answer should be compact. -13.35. In the year 1999, what is the difference between the Cost (as % of GNI) in Energy and Cost (as % of GNI) in Water?
Offer a very short reply. -0.36. In the year 2000, what is the difference between the Cost (as % of GNI) in Coal and Cost (as % of GNI) in Minerals?
Keep it short and to the point. 1.13. In the year 2000, what is the difference between the Cost (as % of GNI) in Coal and Cost (as % of GNI) in Energy?
Your answer should be very brief. -22.1. In the year 2000, what is the difference between the Cost (as % of GNI) in Coal and Cost (as % of GNI) in Water?
Your response must be concise. -22.36. In the year 2000, what is the difference between the Cost (as % of GNI) of Minerals and Cost (as % of GNI) of Energy?
Provide a short and direct response. -23.23. In the year 2000, what is the difference between the Cost (as % of GNI) in Minerals and Cost (as % of GNI) in Water?
Offer a very short reply. -23.49. In the year 2000, what is the difference between the Cost (as % of GNI) of Energy and Cost (as % of GNI) of Water?
Provide a succinct answer. -0.26. In the year 2001, what is the difference between the Cost (as % of GNI) in Coal and Cost (as % of GNI) in Minerals?
Provide a succinct answer. 1.1. In the year 2001, what is the difference between the Cost (as % of GNI) in Coal and Cost (as % of GNI) in Energy?
Keep it short and to the point. -19.05. In the year 2001, what is the difference between the Cost (as % of GNI) in Coal and Cost (as % of GNI) in Water?
Your answer should be very brief. -19.32. In the year 2001, what is the difference between the Cost (as % of GNI) of Minerals and Cost (as % of GNI) of Energy?
Give a very brief answer. -20.15. In the year 2001, what is the difference between the Cost (as % of GNI) of Minerals and Cost (as % of GNI) of Water?
Ensure brevity in your answer.  -20.42. In the year 2001, what is the difference between the Cost (as % of GNI) of Energy and Cost (as % of GNI) of Water?
Your answer should be compact. -0.27. In the year 2002, what is the difference between the Cost (as % of GNI) of Coal and Cost (as % of GNI) of Minerals?
Give a very brief answer. 1.19. In the year 2002, what is the difference between the Cost (as % of GNI) of Coal and Cost (as % of GNI) of Energy?
Offer a terse response. -17.92. In the year 2002, what is the difference between the Cost (as % of GNI) in Coal and Cost (as % of GNI) in Water?
Provide a succinct answer. -18.2. In the year 2002, what is the difference between the Cost (as % of GNI) of Minerals and Cost (as % of GNI) of Energy?
Make the answer very short. -19.11. In the year 2002, what is the difference between the Cost (as % of GNI) of Minerals and Cost (as % of GNI) of Water?
Your answer should be very brief. -19.39. In the year 2002, what is the difference between the Cost (as % of GNI) of Energy and Cost (as % of GNI) of Water?
Provide a succinct answer. -0.29. In the year 2003, what is the difference between the Cost (as % of GNI) in Coal and Cost (as % of GNI) in Minerals?
Your answer should be very brief. 1.04. In the year 2003, what is the difference between the Cost (as % of GNI) in Coal and Cost (as % of GNI) in Energy?
Give a very brief answer. -22.56. In the year 2003, what is the difference between the Cost (as % of GNI) of Coal and Cost (as % of GNI) of Water?
Ensure brevity in your answer.  -22.95. In the year 2003, what is the difference between the Cost (as % of GNI) in Minerals and Cost (as % of GNI) in Energy?
Provide a succinct answer. -23.6. In the year 2003, what is the difference between the Cost (as % of GNI) of Minerals and Cost (as % of GNI) of Water?
Offer a terse response. -23.99. In the year 2003, what is the difference between the Cost (as % of GNI) of Energy and Cost (as % of GNI) of Water?
Your response must be concise. -0.39. In the year 2004, what is the difference between the Cost (as % of GNI) in Coal and Cost (as % of GNI) in Minerals?
Ensure brevity in your answer.  0.83. In the year 2004, what is the difference between the Cost (as % of GNI) of Coal and Cost (as % of GNI) of Energy?
Your answer should be compact. -22.69. In the year 2004, what is the difference between the Cost (as % of GNI) in Coal and Cost (as % of GNI) in Water?
Offer a very short reply. -23. In the year 2004, what is the difference between the Cost (as % of GNI) of Minerals and Cost (as % of GNI) of Energy?
Your answer should be compact. -23.52. In the year 2004, what is the difference between the Cost (as % of GNI) in Minerals and Cost (as % of GNI) in Water?
Keep it short and to the point. -23.83. In the year 2004, what is the difference between the Cost (as % of GNI) in Energy and Cost (as % of GNI) in Water?
Your answer should be very brief. -0.31. What is the ratio of the Cost (as % of GNI) in Coal in 1996 to that in 1997?
Your answer should be compact. 1.11. What is the ratio of the Cost (as % of GNI) of Minerals in 1996 to that in 1997?
Make the answer very short. 1.17. What is the ratio of the Cost (as % of GNI) in Energy in 1996 to that in 1997?
Offer a terse response. 1.06. What is the ratio of the Cost (as % of GNI) of Water in 1996 to that in 1997?
Make the answer very short. 1.06. What is the ratio of the Cost (as % of GNI) of Coal in 1996 to that in 1998?
Ensure brevity in your answer.  0.9. What is the ratio of the Cost (as % of GNI) in Minerals in 1996 to that in 1998?
Offer a very short reply. 0.52. What is the ratio of the Cost (as % of GNI) in Energy in 1996 to that in 1998?
Provide a succinct answer. 1.59. What is the ratio of the Cost (as % of GNI) of Water in 1996 to that in 1998?
Ensure brevity in your answer.  1.56. What is the ratio of the Cost (as % of GNI) of Coal in 1996 to that in 1999?
Your answer should be compact. 1.02. What is the ratio of the Cost (as % of GNI) in Minerals in 1996 to that in 1999?
Give a very brief answer. 0.88. What is the ratio of the Cost (as % of GNI) of Energy in 1996 to that in 1999?
Your response must be concise. 1.31. What is the ratio of the Cost (as % of GNI) in Water in 1996 to that in 1999?
Your response must be concise. 1.3. What is the ratio of the Cost (as % of GNI) in Coal in 1996 to that in 2000?
Keep it short and to the point. 1.16. What is the ratio of the Cost (as % of GNI) of Minerals in 1996 to that in 2000?
Give a very brief answer. 0.67. What is the ratio of the Cost (as % of GNI) of Energy in 1996 to that in 2000?
Make the answer very short. 0.73. What is the ratio of the Cost (as % of GNI) of Water in 1996 to that in 2000?
Offer a terse response. 0.74. What is the ratio of the Cost (as % of GNI) in Coal in 1996 to that in 2001?
Offer a terse response. 1.19. What is the ratio of the Cost (as % of GNI) in Minerals in 1996 to that in 2001?
Your response must be concise. 0.81. What is the ratio of the Cost (as % of GNI) in Energy in 1996 to that in 2001?
Make the answer very short. 0.84. What is the ratio of the Cost (as % of GNI) in Water in 1996 to that in 2001?
Keep it short and to the point. 0.85. What is the ratio of the Cost (as % of GNI) of Coal in 1996 to that in 2002?
Provide a succinct answer. 1.11. What is the ratio of the Cost (as % of GNI) in Minerals in 1996 to that in 2002?
Offer a terse response. 0.87. What is the ratio of the Cost (as % of GNI) of Energy in 1996 to that in 2002?
Your response must be concise. 0.89. What is the ratio of the Cost (as % of GNI) in Water in 1996 to that in 2002?
Offer a terse response. 0.89. What is the ratio of the Cost (as % of GNI) in Coal in 1996 to that in 2003?
Give a very brief answer. 1.26. What is the ratio of the Cost (as % of GNI) of Minerals in 1996 to that in 2003?
Provide a succinct answer. 0.8. What is the ratio of the Cost (as % of GNI) of Energy in 1996 to that in 2003?
Offer a terse response. 0.72. What is the ratio of the Cost (as % of GNI) in Water in 1996 to that in 2003?
Offer a terse response. 0.72. What is the ratio of the Cost (as % of GNI) of Coal in 1996 to that in 2004?
Give a very brief answer. 1.57. What is the ratio of the Cost (as % of GNI) of Minerals in 1996 to that in 2004?
Make the answer very short. 0.66. What is the ratio of the Cost (as % of GNI) of Energy in 1996 to that in 2004?
Ensure brevity in your answer.  0.72. What is the ratio of the Cost (as % of GNI) of Water in 1996 to that in 2004?
Provide a succinct answer. 0.73. What is the ratio of the Cost (as % of GNI) in Coal in 1997 to that in 1998?
Provide a short and direct response. 0.81. What is the ratio of the Cost (as % of GNI) of Minerals in 1997 to that in 1998?
Your answer should be compact. 0.44. What is the ratio of the Cost (as % of GNI) in Energy in 1997 to that in 1998?
Your response must be concise. 1.51. What is the ratio of the Cost (as % of GNI) of Water in 1997 to that in 1998?
Offer a terse response. 1.48. What is the ratio of the Cost (as % of GNI) of Coal in 1997 to that in 1999?
Offer a terse response. 0.92. What is the ratio of the Cost (as % of GNI) of Minerals in 1997 to that in 1999?
Offer a very short reply. 0.75. What is the ratio of the Cost (as % of GNI) of Energy in 1997 to that in 1999?
Offer a terse response. 1.24. What is the ratio of the Cost (as % of GNI) in Water in 1997 to that in 1999?
Ensure brevity in your answer.  1.23. What is the ratio of the Cost (as % of GNI) of Coal in 1997 to that in 2000?
Your answer should be compact. 1.05. What is the ratio of the Cost (as % of GNI) of Minerals in 1997 to that in 2000?
Your answer should be compact. 0.57. What is the ratio of the Cost (as % of GNI) of Energy in 1997 to that in 2000?
Make the answer very short. 0.69. What is the ratio of the Cost (as % of GNI) of Water in 1997 to that in 2000?
Give a very brief answer. 0.7. What is the ratio of the Cost (as % of GNI) in Coal in 1997 to that in 2001?
Your response must be concise. 1.08. What is the ratio of the Cost (as % of GNI) of Minerals in 1997 to that in 2001?
Make the answer very short. 0.69. What is the ratio of the Cost (as % of GNI) in Energy in 1997 to that in 2001?
Provide a succinct answer. 0.8. What is the ratio of the Cost (as % of GNI) in Water in 1997 to that in 2001?
Provide a short and direct response. 0.8. What is the ratio of the Cost (as % of GNI) of Minerals in 1997 to that in 2002?
Your answer should be compact. 0.74. What is the ratio of the Cost (as % of GNI) in Energy in 1997 to that in 2002?
Ensure brevity in your answer.  0.84. What is the ratio of the Cost (as % of GNI) of Water in 1997 to that in 2002?
Provide a short and direct response. 0.85. What is the ratio of the Cost (as % of GNI) in Coal in 1997 to that in 2003?
Your answer should be very brief. 1.14. What is the ratio of the Cost (as % of GNI) of Minerals in 1997 to that in 2003?
Make the answer very short. 0.68. What is the ratio of the Cost (as % of GNI) of Energy in 1997 to that in 2003?
Give a very brief answer. 0.68. What is the ratio of the Cost (as % of GNI) of Water in 1997 to that in 2003?
Keep it short and to the point. 0.68. What is the ratio of the Cost (as % of GNI) in Coal in 1997 to that in 2004?
Provide a short and direct response. 1.42. What is the ratio of the Cost (as % of GNI) of Minerals in 1997 to that in 2004?
Give a very brief answer. 0.56. What is the ratio of the Cost (as % of GNI) of Energy in 1997 to that in 2004?
Offer a very short reply. 0.68. What is the ratio of the Cost (as % of GNI) in Water in 1997 to that in 2004?
Provide a short and direct response. 0.69. What is the ratio of the Cost (as % of GNI) of Coal in 1998 to that in 1999?
Make the answer very short. 1.14. What is the ratio of the Cost (as % of GNI) of Minerals in 1998 to that in 1999?
Give a very brief answer. 1.69. What is the ratio of the Cost (as % of GNI) of Energy in 1998 to that in 1999?
Provide a short and direct response. 0.82. What is the ratio of the Cost (as % of GNI) of Water in 1998 to that in 1999?
Ensure brevity in your answer.  0.83. What is the ratio of the Cost (as % of GNI) in Coal in 1998 to that in 2000?
Offer a terse response. 1.29. What is the ratio of the Cost (as % of GNI) in Minerals in 1998 to that in 2000?
Give a very brief answer. 1.29. What is the ratio of the Cost (as % of GNI) of Energy in 1998 to that in 2000?
Keep it short and to the point. 0.46. What is the ratio of the Cost (as % of GNI) in Water in 1998 to that in 2000?
Give a very brief answer. 0.47. What is the ratio of the Cost (as % of GNI) in Coal in 1998 to that in 2001?
Keep it short and to the point. 1.33. What is the ratio of the Cost (as % of GNI) in Minerals in 1998 to that in 2001?
Your response must be concise. 1.56. What is the ratio of the Cost (as % of GNI) in Energy in 1998 to that in 2001?
Give a very brief answer. 0.53. What is the ratio of the Cost (as % of GNI) of Water in 1998 to that in 2001?
Your answer should be compact. 0.54. What is the ratio of the Cost (as % of GNI) of Coal in 1998 to that in 2002?
Offer a very short reply. 1.23. What is the ratio of the Cost (as % of GNI) in Minerals in 1998 to that in 2002?
Keep it short and to the point. 1.67. What is the ratio of the Cost (as % of GNI) in Energy in 1998 to that in 2002?
Give a very brief answer. 0.56. What is the ratio of the Cost (as % of GNI) in Water in 1998 to that in 2002?
Give a very brief answer. 0.57. What is the ratio of the Cost (as % of GNI) in Coal in 1998 to that in 2003?
Provide a short and direct response. 1.41. What is the ratio of the Cost (as % of GNI) in Minerals in 1998 to that in 2003?
Give a very brief answer. 1.54. What is the ratio of the Cost (as % of GNI) of Energy in 1998 to that in 2003?
Provide a succinct answer. 0.45. What is the ratio of the Cost (as % of GNI) of Water in 1998 to that in 2003?
Provide a short and direct response. 0.46. What is the ratio of the Cost (as % of GNI) in Coal in 1998 to that in 2004?
Make the answer very short. 1.75. What is the ratio of the Cost (as % of GNI) of Minerals in 1998 to that in 2004?
Make the answer very short. 1.26. What is the ratio of the Cost (as % of GNI) in Energy in 1998 to that in 2004?
Give a very brief answer. 0.45. What is the ratio of the Cost (as % of GNI) of Water in 1998 to that in 2004?
Your answer should be very brief. 0.47. What is the ratio of the Cost (as % of GNI) in Coal in 1999 to that in 2000?
Give a very brief answer. 1.14. What is the ratio of the Cost (as % of GNI) in Minerals in 1999 to that in 2000?
Your answer should be very brief. 0.77. What is the ratio of the Cost (as % of GNI) of Energy in 1999 to that in 2000?
Provide a short and direct response. 0.56. What is the ratio of the Cost (as % of GNI) of Water in 1999 to that in 2000?
Make the answer very short. 0.57. What is the ratio of the Cost (as % of GNI) in Coal in 1999 to that in 2001?
Make the answer very short. 1.17. What is the ratio of the Cost (as % of GNI) of Minerals in 1999 to that in 2001?
Offer a very short reply. 0.92. What is the ratio of the Cost (as % of GNI) in Energy in 1999 to that in 2001?
Your answer should be compact. 0.64. What is the ratio of the Cost (as % of GNI) of Water in 1999 to that in 2001?
Ensure brevity in your answer.  0.65. What is the ratio of the Cost (as % of GNI) in Coal in 1999 to that in 2002?
Ensure brevity in your answer.  1.09. What is the ratio of the Cost (as % of GNI) of Energy in 1999 to that in 2002?
Provide a succinct answer. 0.68. What is the ratio of the Cost (as % of GNI) in Water in 1999 to that in 2002?
Your answer should be very brief. 0.69. What is the ratio of the Cost (as % of GNI) of Coal in 1999 to that in 2003?
Offer a terse response. 1.24. What is the ratio of the Cost (as % of GNI) of Minerals in 1999 to that in 2003?
Offer a terse response. 0.91. What is the ratio of the Cost (as % of GNI) in Energy in 1999 to that in 2003?
Ensure brevity in your answer.  0.55. What is the ratio of the Cost (as % of GNI) in Water in 1999 to that in 2003?
Offer a very short reply. 0.56. What is the ratio of the Cost (as % of GNI) of Coal in 1999 to that in 2004?
Ensure brevity in your answer.  1.54. What is the ratio of the Cost (as % of GNI) of Minerals in 1999 to that in 2004?
Give a very brief answer. 0.75. What is the ratio of the Cost (as % of GNI) in Energy in 1999 to that in 2004?
Offer a terse response. 0.55. What is the ratio of the Cost (as % of GNI) in Water in 1999 to that in 2004?
Your answer should be very brief. 0.56. What is the ratio of the Cost (as % of GNI) in Coal in 2000 to that in 2001?
Provide a succinct answer. 1.03. What is the ratio of the Cost (as % of GNI) in Minerals in 2000 to that in 2001?
Your answer should be compact. 1.21. What is the ratio of the Cost (as % of GNI) in Energy in 2000 to that in 2001?
Keep it short and to the point. 1.15. What is the ratio of the Cost (as % of GNI) of Water in 2000 to that in 2001?
Your response must be concise. 1.15. What is the ratio of the Cost (as % of GNI) of Coal in 2000 to that in 2002?
Give a very brief answer. 0.95. What is the ratio of the Cost (as % of GNI) of Minerals in 2000 to that in 2002?
Provide a succinct answer. 1.29. What is the ratio of the Cost (as % of GNI) of Energy in 2000 to that in 2002?
Provide a succinct answer. 1.22. What is the ratio of the Cost (as % of GNI) in Water in 2000 to that in 2002?
Ensure brevity in your answer.  1.21. What is the ratio of the Cost (as % of GNI) in Coal in 2000 to that in 2003?
Provide a short and direct response. 1.09. What is the ratio of the Cost (as % of GNI) in Minerals in 2000 to that in 2003?
Provide a succinct answer. 1.19. What is the ratio of the Cost (as % of GNI) of Energy in 2000 to that in 2003?
Keep it short and to the point. 0.98. What is the ratio of the Cost (as % of GNI) of Water in 2000 to that in 2003?
Provide a short and direct response. 0.98. What is the ratio of the Cost (as % of GNI) of Coal in 2000 to that in 2004?
Your answer should be very brief. 1.35. What is the ratio of the Cost (as % of GNI) of Minerals in 2000 to that in 2004?
Give a very brief answer. 0.98. What is the ratio of the Cost (as % of GNI) in Water in 2000 to that in 2004?
Offer a terse response. 0.99. What is the ratio of the Cost (as % of GNI) in Coal in 2001 to that in 2002?
Offer a very short reply. 0.93. What is the ratio of the Cost (as % of GNI) in Minerals in 2001 to that in 2002?
Ensure brevity in your answer.  1.07. What is the ratio of the Cost (as % of GNI) of Energy in 2001 to that in 2002?
Your answer should be compact. 1.05. What is the ratio of the Cost (as % of GNI) in Water in 2001 to that in 2002?
Offer a very short reply. 1.05. What is the ratio of the Cost (as % of GNI) of Coal in 2001 to that in 2003?
Give a very brief answer. 1.06. What is the ratio of the Cost (as % of GNI) in Minerals in 2001 to that in 2003?
Offer a terse response. 0.99. What is the ratio of the Cost (as % of GNI) in Energy in 2001 to that in 2003?
Provide a succinct answer. 0.85. What is the ratio of the Cost (as % of GNI) in Water in 2001 to that in 2003?
Your answer should be compact. 0.85. What is the ratio of the Cost (as % of GNI) of Coal in 2001 to that in 2004?
Provide a succinct answer. 1.32. What is the ratio of the Cost (as % of GNI) of Minerals in 2001 to that in 2004?
Offer a very short reply. 0.81. What is the ratio of the Cost (as % of GNI) in Energy in 2001 to that in 2004?
Offer a terse response. 0.86. What is the ratio of the Cost (as % of GNI) of Water in 2001 to that in 2004?
Your response must be concise. 0.86. What is the ratio of the Cost (as % of GNI) of Coal in 2002 to that in 2003?
Provide a succinct answer. 1.14. What is the ratio of the Cost (as % of GNI) in Minerals in 2002 to that in 2003?
Make the answer very short. 0.92. What is the ratio of the Cost (as % of GNI) of Energy in 2002 to that in 2003?
Provide a short and direct response. 0.81. What is the ratio of the Cost (as % of GNI) in Water in 2002 to that in 2003?
Offer a very short reply. 0.81. What is the ratio of the Cost (as % of GNI) of Coal in 2002 to that in 2004?
Your response must be concise. 1.42. What is the ratio of the Cost (as % of GNI) of Minerals in 2002 to that in 2004?
Provide a short and direct response. 0.76. What is the ratio of the Cost (as % of GNI) in Energy in 2002 to that in 2004?
Give a very brief answer. 0.81. What is the ratio of the Cost (as % of GNI) in Water in 2002 to that in 2004?
Provide a short and direct response. 0.81. What is the ratio of the Cost (as % of GNI) of Coal in 2003 to that in 2004?
Keep it short and to the point. 1.24. What is the ratio of the Cost (as % of GNI) in Minerals in 2003 to that in 2004?
Provide a short and direct response. 0.82. What is the ratio of the Cost (as % of GNI) in Energy in 2003 to that in 2004?
Your answer should be compact. 1. What is the difference between the highest and the second highest Cost (as % of GNI) in Coal?
Provide a succinct answer. 0.15. What is the difference between the highest and the second highest Cost (as % of GNI) in Minerals?
Your response must be concise. 0.01. What is the difference between the highest and the second highest Cost (as % of GNI) of Energy?
Offer a very short reply. 0.08. What is the difference between the highest and the second highest Cost (as % of GNI) in Water?
Give a very brief answer. 0.15. What is the difference between the highest and the lowest Cost (as % of GNI) of Coal?
Offer a very short reply. 0.64. What is the difference between the highest and the lowest Cost (as % of GNI) in Minerals?
Your answer should be very brief. 0.01. What is the difference between the highest and the lowest Cost (as % of GNI) in Energy?
Offer a very short reply. 12.94. What is the difference between the highest and the lowest Cost (as % of GNI) in Water?
Ensure brevity in your answer.  12.91. 